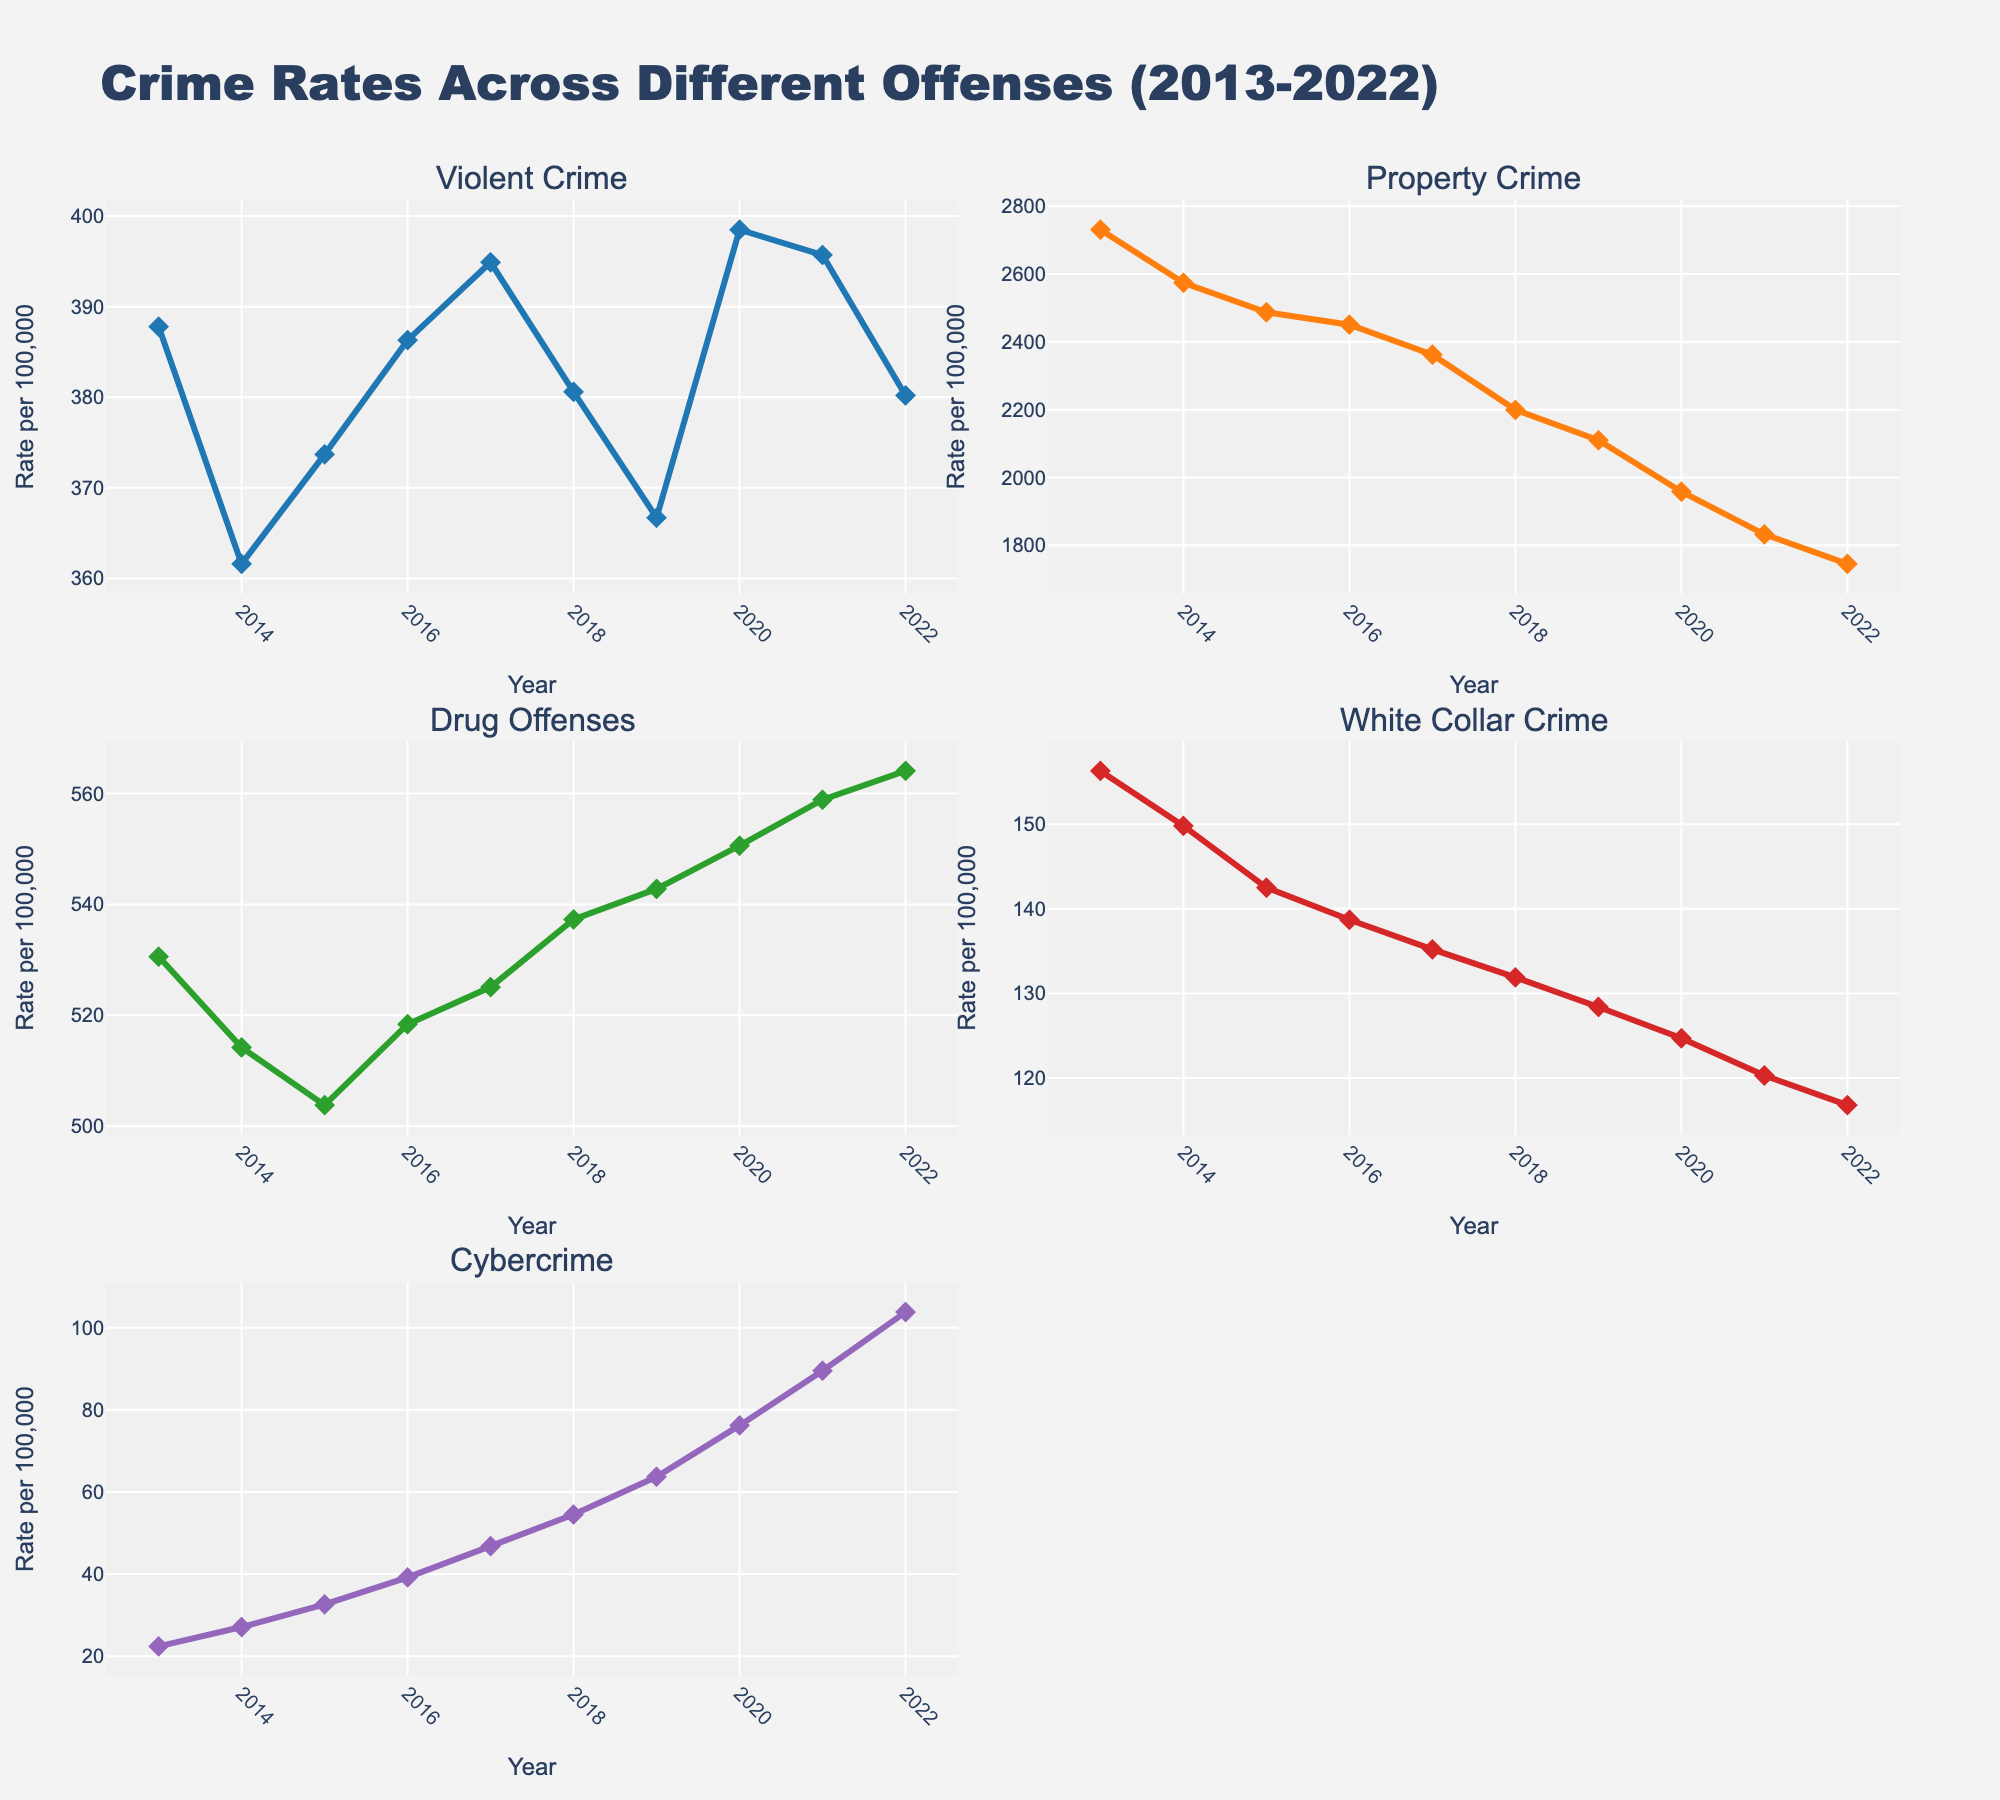What is the title of the figure? The title is usually displayed at the top of the figure. In this subplot, it reads "Crime Rates Across Different Offenses (2013-2022)".
Answer: Crime Rates Across Different Offenses (2013-2022) How many subplots are there in the figure? By visually counting the individual sections or panels within the figure, it’s clear that there are five subplots.
Answer: Five Identify the Years where Violent Crime rates decreased compared to the previous year? To identify these years, look at the Violent Crime subplot and observe the trend of the line. Key points are 2014 (compared to 2013), 2015 (compared to 2014), 2018 (compared to 2017), 2019 (compared to 2018), and 2022 (compared to 2021).
Answer: 2014, 2015, 2018, 2019, 2022 Which crime type shows the highest rate in 2022? By comparing the last data points for each subplot, we can see that Property Crime has the highest rate among all types of offenses in 2022.
Answer: Property Crime What is the general trend of Cybercrime from 2013 to 2022? To understand this, we observe the Cybercrime subplot. The line shows a clear upward trend as the values increase each year.
Answer: Increasing Which year had the lowest rate of White Collar Crime and what was the rate? Look at the lowest point on the White Collar Crime subplot and note the year on the x-axis and the corresponding value on the y-axis. The lowest rate was in 2022 with a rate of 116.8.
Answer: 2022, 116.8 Compare the trends of Drug Offenses and Cybercrime from 2013 to 2022. What can you infer? By examining both subplots, Drug Offenses show a steady increase over the years, while Cybercrime shows a sharper and more consistent increase starting from a much lower point. Both have upward trends, but Cybercrime’s rate of increase is more pronounced.
Answer: Both trends are increasing, but Cybercrime is increasing more rapidly and consistently Do Violent Crime and Property Crime rates show similar trends over the past decade? By comparing these two subplots, we see that both trends generally show a decline over time, though Violent Crime has a slight peak around 2020 while Property Crime consistently decreases.
Answer: Similar downward trends, with a slight peak in Violent Crime around 2020 How has the rate of Drug Offenses changed from 2013 to 2022? To determine this, look at the Drug Offenses subplot's change from the first to the last data point. The rate increased from 530.6 in 2013 to 564.1 in 2022.
Answer: Increased from 530.6 to 564.1 Which two years saw the most significant drop in Property Crime rates? Look at the Property Crime subplot and identify the steepest declines. The most significant drops occurred between 2017 and 2018, and 2020 and 2021.
Answer: 2017-2018 and 2020-2021 